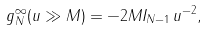Convert formula to latex. <formula><loc_0><loc_0><loc_500><loc_500>g _ { N } ^ { \infty } ( u \gg M ) = - 2 M I _ { N - 1 } \, u ^ { - 2 } ,</formula> 